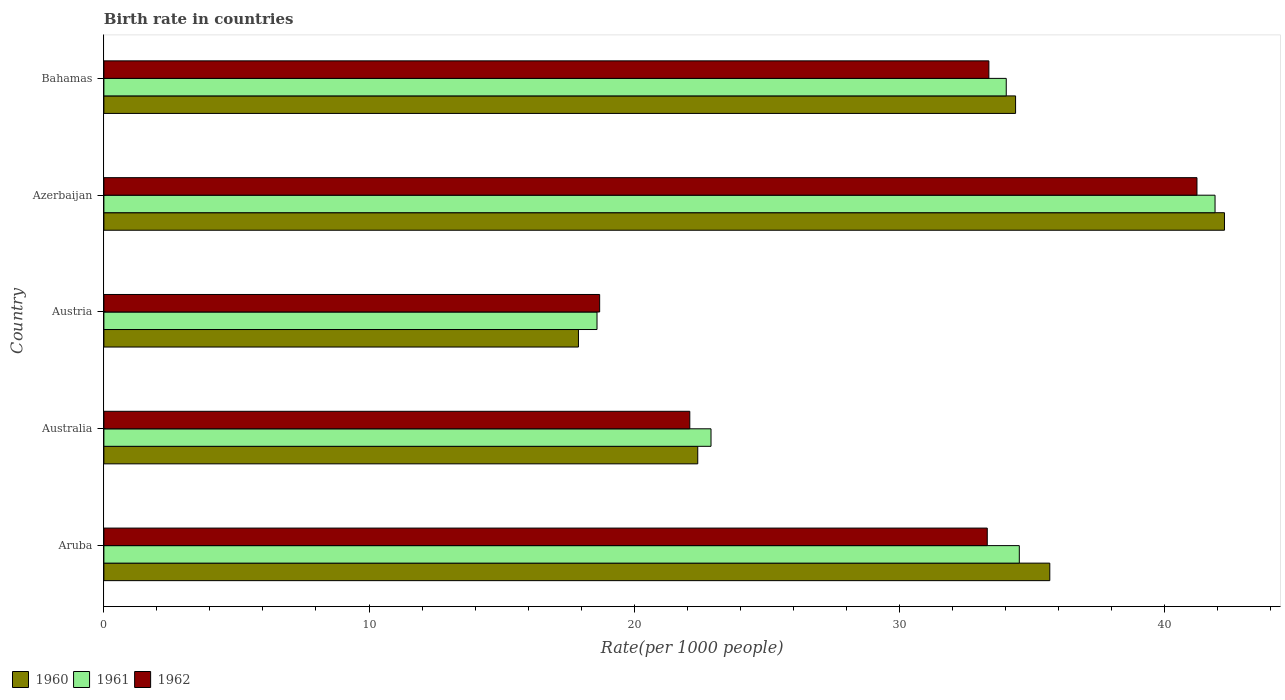How many different coloured bars are there?
Ensure brevity in your answer.  3. What is the label of the 2nd group of bars from the top?
Offer a very short reply. Azerbaijan. In how many cases, is the number of bars for a given country not equal to the number of legend labels?
Give a very brief answer. 0. What is the birth rate in 1962 in Aruba?
Your response must be concise. 33.32. Across all countries, what is the maximum birth rate in 1960?
Provide a short and direct response. 42.27. Across all countries, what is the minimum birth rate in 1962?
Give a very brief answer. 18.7. In which country was the birth rate in 1960 maximum?
Your response must be concise. Azerbaijan. What is the total birth rate in 1961 in the graph?
Offer a terse response. 151.98. What is the difference between the birth rate in 1960 in Austria and that in Azerbaijan?
Your response must be concise. -24.37. What is the difference between the birth rate in 1962 in Austria and the birth rate in 1961 in Australia?
Your answer should be very brief. -4.2. What is the average birth rate in 1960 per country?
Provide a succinct answer. 30.53. What is the difference between the birth rate in 1960 and birth rate in 1961 in Australia?
Offer a terse response. -0.5. In how many countries, is the birth rate in 1961 greater than 28 ?
Offer a terse response. 3. What is the ratio of the birth rate in 1960 in Aruba to that in Azerbaijan?
Provide a short and direct response. 0.84. Is the birth rate in 1961 in Australia less than that in Bahamas?
Provide a short and direct response. Yes. What is the difference between the highest and the second highest birth rate in 1960?
Offer a very short reply. 6.59. What is the difference between the highest and the lowest birth rate in 1961?
Provide a succinct answer. 23.31. Is the sum of the birth rate in 1961 in Aruba and Azerbaijan greater than the maximum birth rate in 1960 across all countries?
Make the answer very short. Yes. What does the 1st bar from the top in Azerbaijan represents?
Keep it short and to the point. 1962. How many bars are there?
Ensure brevity in your answer.  15. How many countries are there in the graph?
Offer a very short reply. 5. Are the values on the major ticks of X-axis written in scientific E-notation?
Your response must be concise. No. How many legend labels are there?
Ensure brevity in your answer.  3. How are the legend labels stacked?
Offer a very short reply. Horizontal. What is the title of the graph?
Offer a terse response. Birth rate in countries. Does "1993" appear as one of the legend labels in the graph?
Your answer should be very brief. No. What is the label or title of the X-axis?
Make the answer very short. Rate(per 1000 people). What is the label or title of the Y-axis?
Offer a terse response. Country. What is the Rate(per 1000 people) in 1960 in Aruba?
Provide a short and direct response. 35.68. What is the Rate(per 1000 people) of 1961 in Aruba?
Your response must be concise. 34.53. What is the Rate(per 1000 people) of 1962 in Aruba?
Offer a terse response. 33.32. What is the Rate(per 1000 people) of 1960 in Australia?
Offer a very short reply. 22.4. What is the Rate(per 1000 people) of 1961 in Australia?
Provide a succinct answer. 22.9. What is the Rate(per 1000 people) of 1962 in Australia?
Make the answer very short. 22.1. What is the Rate(per 1000 people) of 1960 in Azerbaijan?
Give a very brief answer. 42.27. What is the Rate(per 1000 people) of 1961 in Azerbaijan?
Make the answer very short. 41.91. What is the Rate(per 1000 people) in 1962 in Azerbaijan?
Make the answer very short. 41.23. What is the Rate(per 1000 people) in 1960 in Bahamas?
Your answer should be very brief. 34.39. What is the Rate(per 1000 people) of 1961 in Bahamas?
Provide a short and direct response. 34.04. What is the Rate(per 1000 people) of 1962 in Bahamas?
Your answer should be very brief. 33.38. Across all countries, what is the maximum Rate(per 1000 people) in 1960?
Provide a short and direct response. 42.27. Across all countries, what is the maximum Rate(per 1000 people) of 1961?
Provide a succinct answer. 41.91. Across all countries, what is the maximum Rate(per 1000 people) in 1962?
Give a very brief answer. 41.23. Across all countries, what is the minimum Rate(per 1000 people) in 1962?
Offer a very short reply. 18.7. What is the total Rate(per 1000 people) of 1960 in the graph?
Offer a very short reply. 152.63. What is the total Rate(per 1000 people) of 1961 in the graph?
Offer a terse response. 151.98. What is the total Rate(per 1000 people) in 1962 in the graph?
Keep it short and to the point. 148.73. What is the difference between the Rate(per 1000 people) of 1960 in Aruba and that in Australia?
Offer a terse response. 13.28. What is the difference between the Rate(per 1000 people) in 1961 in Aruba and that in Australia?
Your answer should be compact. 11.63. What is the difference between the Rate(per 1000 people) of 1962 in Aruba and that in Australia?
Offer a very short reply. 11.22. What is the difference between the Rate(per 1000 people) in 1960 in Aruba and that in Austria?
Your response must be concise. 17.78. What is the difference between the Rate(per 1000 people) of 1961 in Aruba and that in Austria?
Your response must be concise. 15.93. What is the difference between the Rate(per 1000 people) in 1962 in Aruba and that in Austria?
Give a very brief answer. 14.62. What is the difference between the Rate(per 1000 people) in 1960 in Aruba and that in Azerbaijan?
Keep it short and to the point. -6.59. What is the difference between the Rate(per 1000 people) in 1961 in Aruba and that in Azerbaijan?
Your answer should be very brief. -7.38. What is the difference between the Rate(per 1000 people) in 1962 in Aruba and that in Azerbaijan?
Provide a succinct answer. -7.91. What is the difference between the Rate(per 1000 people) of 1960 in Aruba and that in Bahamas?
Offer a terse response. 1.29. What is the difference between the Rate(per 1000 people) in 1961 in Aruba and that in Bahamas?
Offer a terse response. 0.49. What is the difference between the Rate(per 1000 people) in 1962 in Aruba and that in Bahamas?
Ensure brevity in your answer.  -0.06. What is the difference between the Rate(per 1000 people) of 1961 in Australia and that in Austria?
Make the answer very short. 4.3. What is the difference between the Rate(per 1000 people) of 1962 in Australia and that in Austria?
Provide a succinct answer. 3.4. What is the difference between the Rate(per 1000 people) in 1960 in Australia and that in Azerbaijan?
Offer a very short reply. -19.87. What is the difference between the Rate(per 1000 people) in 1961 in Australia and that in Azerbaijan?
Provide a succinct answer. -19.01. What is the difference between the Rate(per 1000 people) in 1962 in Australia and that in Azerbaijan?
Provide a short and direct response. -19.13. What is the difference between the Rate(per 1000 people) of 1960 in Australia and that in Bahamas?
Your answer should be compact. -11.99. What is the difference between the Rate(per 1000 people) in 1961 in Australia and that in Bahamas?
Your response must be concise. -11.14. What is the difference between the Rate(per 1000 people) in 1962 in Australia and that in Bahamas?
Your answer should be compact. -11.28. What is the difference between the Rate(per 1000 people) of 1960 in Austria and that in Azerbaijan?
Provide a short and direct response. -24.37. What is the difference between the Rate(per 1000 people) in 1961 in Austria and that in Azerbaijan?
Make the answer very short. -23.31. What is the difference between the Rate(per 1000 people) in 1962 in Austria and that in Azerbaijan?
Your response must be concise. -22.53. What is the difference between the Rate(per 1000 people) of 1960 in Austria and that in Bahamas?
Your answer should be compact. -16.49. What is the difference between the Rate(per 1000 people) of 1961 in Austria and that in Bahamas?
Offer a terse response. -15.44. What is the difference between the Rate(per 1000 people) in 1962 in Austria and that in Bahamas?
Offer a very short reply. -14.68. What is the difference between the Rate(per 1000 people) in 1960 in Azerbaijan and that in Bahamas?
Your response must be concise. 7.88. What is the difference between the Rate(per 1000 people) in 1961 in Azerbaijan and that in Bahamas?
Make the answer very short. 7.88. What is the difference between the Rate(per 1000 people) in 1962 in Azerbaijan and that in Bahamas?
Provide a succinct answer. 7.85. What is the difference between the Rate(per 1000 people) in 1960 in Aruba and the Rate(per 1000 people) in 1961 in Australia?
Your response must be concise. 12.78. What is the difference between the Rate(per 1000 people) of 1960 in Aruba and the Rate(per 1000 people) of 1962 in Australia?
Offer a terse response. 13.58. What is the difference between the Rate(per 1000 people) in 1961 in Aruba and the Rate(per 1000 people) in 1962 in Australia?
Your answer should be compact. 12.43. What is the difference between the Rate(per 1000 people) in 1960 in Aruba and the Rate(per 1000 people) in 1961 in Austria?
Provide a short and direct response. 17.08. What is the difference between the Rate(per 1000 people) of 1960 in Aruba and the Rate(per 1000 people) of 1962 in Austria?
Provide a succinct answer. 16.98. What is the difference between the Rate(per 1000 people) in 1961 in Aruba and the Rate(per 1000 people) in 1962 in Austria?
Ensure brevity in your answer.  15.83. What is the difference between the Rate(per 1000 people) in 1960 in Aruba and the Rate(per 1000 people) in 1961 in Azerbaijan?
Make the answer very short. -6.23. What is the difference between the Rate(per 1000 people) in 1960 in Aruba and the Rate(per 1000 people) in 1962 in Azerbaijan?
Make the answer very short. -5.55. What is the difference between the Rate(per 1000 people) in 1961 in Aruba and the Rate(per 1000 people) in 1962 in Azerbaijan?
Provide a succinct answer. -6.7. What is the difference between the Rate(per 1000 people) in 1960 in Aruba and the Rate(per 1000 people) in 1961 in Bahamas?
Provide a succinct answer. 1.64. What is the difference between the Rate(per 1000 people) of 1960 in Aruba and the Rate(per 1000 people) of 1962 in Bahamas?
Provide a succinct answer. 2.3. What is the difference between the Rate(per 1000 people) in 1961 in Aruba and the Rate(per 1000 people) in 1962 in Bahamas?
Ensure brevity in your answer.  1.15. What is the difference between the Rate(per 1000 people) of 1960 in Australia and the Rate(per 1000 people) of 1961 in Austria?
Your answer should be very brief. 3.8. What is the difference between the Rate(per 1000 people) of 1960 in Australia and the Rate(per 1000 people) of 1962 in Austria?
Provide a short and direct response. 3.7. What is the difference between the Rate(per 1000 people) of 1961 in Australia and the Rate(per 1000 people) of 1962 in Austria?
Keep it short and to the point. 4.2. What is the difference between the Rate(per 1000 people) of 1960 in Australia and the Rate(per 1000 people) of 1961 in Azerbaijan?
Offer a very short reply. -19.51. What is the difference between the Rate(per 1000 people) in 1960 in Australia and the Rate(per 1000 people) in 1962 in Azerbaijan?
Your answer should be compact. -18.83. What is the difference between the Rate(per 1000 people) of 1961 in Australia and the Rate(per 1000 people) of 1962 in Azerbaijan?
Keep it short and to the point. -18.33. What is the difference between the Rate(per 1000 people) of 1960 in Australia and the Rate(per 1000 people) of 1961 in Bahamas?
Offer a very short reply. -11.64. What is the difference between the Rate(per 1000 people) of 1960 in Australia and the Rate(per 1000 people) of 1962 in Bahamas?
Your response must be concise. -10.98. What is the difference between the Rate(per 1000 people) in 1961 in Australia and the Rate(per 1000 people) in 1962 in Bahamas?
Make the answer very short. -10.48. What is the difference between the Rate(per 1000 people) of 1960 in Austria and the Rate(per 1000 people) of 1961 in Azerbaijan?
Make the answer very short. -24.01. What is the difference between the Rate(per 1000 people) in 1960 in Austria and the Rate(per 1000 people) in 1962 in Azerbaijan?
Your response must be concise. -23.33. What is the difference between the Rate(per 1000 people) of 1961 in Austria and the Rate(per 1000 people) of 1962 in Azerbaijan?
Keep it short and to the point. -22.63. What is the difference between the Rate(per 1000 people) in 1960 in Austria and the Rate(per 1000 people) in 1961 in Bahamas?
Your answer should be very brief. -16.14. What is the difference between the Rate(per 1000 people) in 1960 in Austria and the Rate(per 1000 people) in 1962 in Bahamas?
Offer a terse response. -15.48. What is the difference between the Rate(per 1000 people) in 1961 in Austria and the Rate(per 1000 people) in 1962 in Bahamas?
Ensure brevity in your answer.  -14.78. What is the difference between the Rate(per 1000 people) in 1960 in Azerbaijan and the Rate(per 1000 people) in 1961 in Bahamas?
Give a very brief answer. 8.23. What is the difference between the Rate(per 1000 people) in 1960 in Azerbaijan and the Rate(per 1000 people) in 1962 in Bahamas?
Keep it short and to the point. 8.89. What is the difference between the Rate(per 1000 people) in 1961 in Azerbaijan and the Rate(per 1000 people) in 1962 in Bahamas?
Provide a short and direct response. 8.53. What is the average Rate(per 1000 people) in 1960 per country?
Provide a short and direct response. 30.53. What is the average Rate(per 1000 people) in 1961 per country?
Offer a very short reply. 30.4. What is the average Rate(per 1000 people) of 1962 per country?
Give a very brief answer. 29.75. What is the difference between the Rate(per 1000 people) in 1960 and Rate(per 1000 people) in 1961 in Aruba?
Offer a terse response. 1.15. What is the difference between the Rate(per 1000 people) in 1960 and Rate(per 1000 people) in 1962 in Aruba?
Ensure brevity in your answer.  2.36. What is the difference between the Rate(per 1000 people) of 1961 and Rate(per 1000 people) of 1962 in Aruba?
Offer a terse response. 1.21. What is the difference between the Rate(per 1000 people) of 1961 and Rate(per 1000 people) of 1962 in Australia?
Your answer should be compact. 0.8. What is the difference between the Rate(per 1000 people) in 1960 and Rate(per 1000 people) in 1961 in Austria?
Make the answer very short. -0.7. What is the difference between the Rate(per 1000 people) in 1960 and Rate(per 1000 people) in 1962 in Austria?
Your response must be concise. -0.8. What is the difference between the Rate(per 1000 people) of 1961 and Rate(per 1000 people) of 1962 in Austria?
Keep it short and to the point. -0.1. What is the difference between the Rate(per 1000 people) in 1960 and Rate(per 1000 people) in 1961 in Azerbaijan?
Offer a terse response. 0.35. What is the difference between the Rate(per 1000 people) in 1960 and Rate(per 1000 people) in 1962 in Azerbaijan?
Provide a succinct answer. 1.04. What is the difference between the Rate(per 1000 people) in 1961 and Rate(per 1000 people) in 1962 in Azerbaijan?
Give a very brief answer. 0.68. What is the difference between the Rate(per 1000 people) in 1960 and Rate(per 1000 people) in 1961 in Bahamas?
Give a very brief answer. 0.35. What is the difference between the Rate(per 1000 people) of 1961 and Rate(per 1000 people) of 1962 in Bahamas?
Offer a terse response. 0.66. What is the ratio of the Rate(per 1000 people) of 1960 in Aruba to that in Australia?
Provide a succinct answer. 1.59. What is the ratio of the Rate(per 1000 people) of 1961 in Aruba to that in Australia?
Provide a short and direct response. 1.51. What is the ratio of the Rate(per 1000 people) of 1962 in Aruba to that in Australia?
Offer a terse response. 1.51. What is the ratio of the Rate(per 1000 people) of 1960 in Aruba to that in Austria?
Offer a very short reply. 1.99. What is the ratio of the Rate(per 1000 people) in 1961 in Aruba to that in Austria?
Offer a terse response. 1.86. What is the ratio of the Rate(per 1000 people) of 1962 in Aruba to that in Austria?
Your response must be concise. 1.78. What is the ratio of the Rate(per 1000 people) in 1960 in Aruba to that in Azerbaijan?
Offer a very short reply. 0.84. What is the ratio of the Rate(per 1000 people) of 1961 in Aruba to that in Azerbaijan?
Offer a terse response. 0.82. What is the ratio of the Rate(per 1000 people) of 1962 in Aruba to that in Azerbaijan?
Provide a short and direct response. 0.81. What is the ratio of the Rate(per 1000 people) of 1960 in Aruba to that in Bahamas?
Your answer should be compact. 1.04. What is the ratio of the Rate(per 1000 people) of 1961 in Aruba to that in Bahamas?
Ensure brevity in your answer.  1.01. What is the ratio of the Rate(per 1000 people) of 1960 in Australia to that in Austria?
Your answer should be very brief. 1.25. What is the ratio of the Rate(per 1000 people) in 1961 in Australia to that in Austria?
Your response must be concise. 1.23. What is the ratio of the Rate(per 1000 people) of 1962 in Australia to that in Austria?
Your answer should be compact. 1.18. What is the ratio of the Rate(per 1000 people) of 1960 in Australia to that in Azerbaijan?
Ensure brevity in your answer.  0.53. What is the ratio of the Rate(per 1000 people) in 1961 in Australia to that in Azerbaijan?
Your response must be concise. 0.55. What is the ratio of the Rate(per 1000 people) of 1962 in Australia to that in Azerbaijan?
Your response must be concise. 0.54. What is the ratio of the Rate(per 1000 people) of 1960 in Australia to that in Bahamas?
Provide a succinct answer. 0.65. What is the ratio of the Rate(per 1000 people) in 1961 in Australia to that in Bahamas?
Offer a terse response. 0.67. What is the ratio of the Rate(per 1000 people) in 1962 in Australia to that in Bahamas?
Your response must be concise. 0.66. What is the ratio of the Rate(per 1000 people) of 1960 in Austria to that in Azerbaijan?
Your answer should be compact. 0.42. What is the ratio of the Rate(per 1000 people) in 1961 in Austria to that in Azerbaijan?
Your answer should be compact. 0.44. What is the ratio of the Rate(per 1000 people) in 1962 in Austria to that in Azerbaijan?
Provide a short and direct response. 0.45. What is the ratio of the Rate(per 1000 people) of 1960 in Austria to that in Bahamas?
Provide a short and direct response. 0.52. What is the ratio of the Rate(per 1000 people) in 1961 in Austria to that in Bahamas?
Give a very brief answer. 0.55. What is the ratio of the Rate(per 1000 people) of 1962 in Austria to that in Bahamas?
Give a very brief answer. 0.56. What is the ratio of the Rate(per 1000 people) in 1960 in Azerbaijan to that in Bahamas?
Provide a short and direct response. 1.23. What is the ratio of the Rate(per 1000 people) in 1961 in Azerbaijan to that in Bahamas?
Your answer should be compact. 1.23. What is the ratio of the Rate(per 1000 people) of 1962 in Azerbaijan to that in Bahamas?
Provide a succinct answer. 1.24. What is the difference between the highest and the second highest Rate(per 1000 people) in 1960?
Provide a short and direct response. 6.59. What is the difference between the highest and the second highest Rate(per 1000 people) in 1961?
Keep it short and to the point. 7.38. What is the difference between the highest and the second highest Rate(per 1000 people) in 1962?
Your answer should be compact. 7.85. What is the difference between the highest and the lowest Rate(per 1000 people) of 1960?
Keep it short and to the point. 24.37. What is the difference between the highest and the lowest Rate(per 1000 people) in 1961?
Ensure brevity in your answer.  23.31. What is the difference between the highest and the lowest Rate(per 1000 people) of 1962?
Provide a short and direct response. 22.53. 